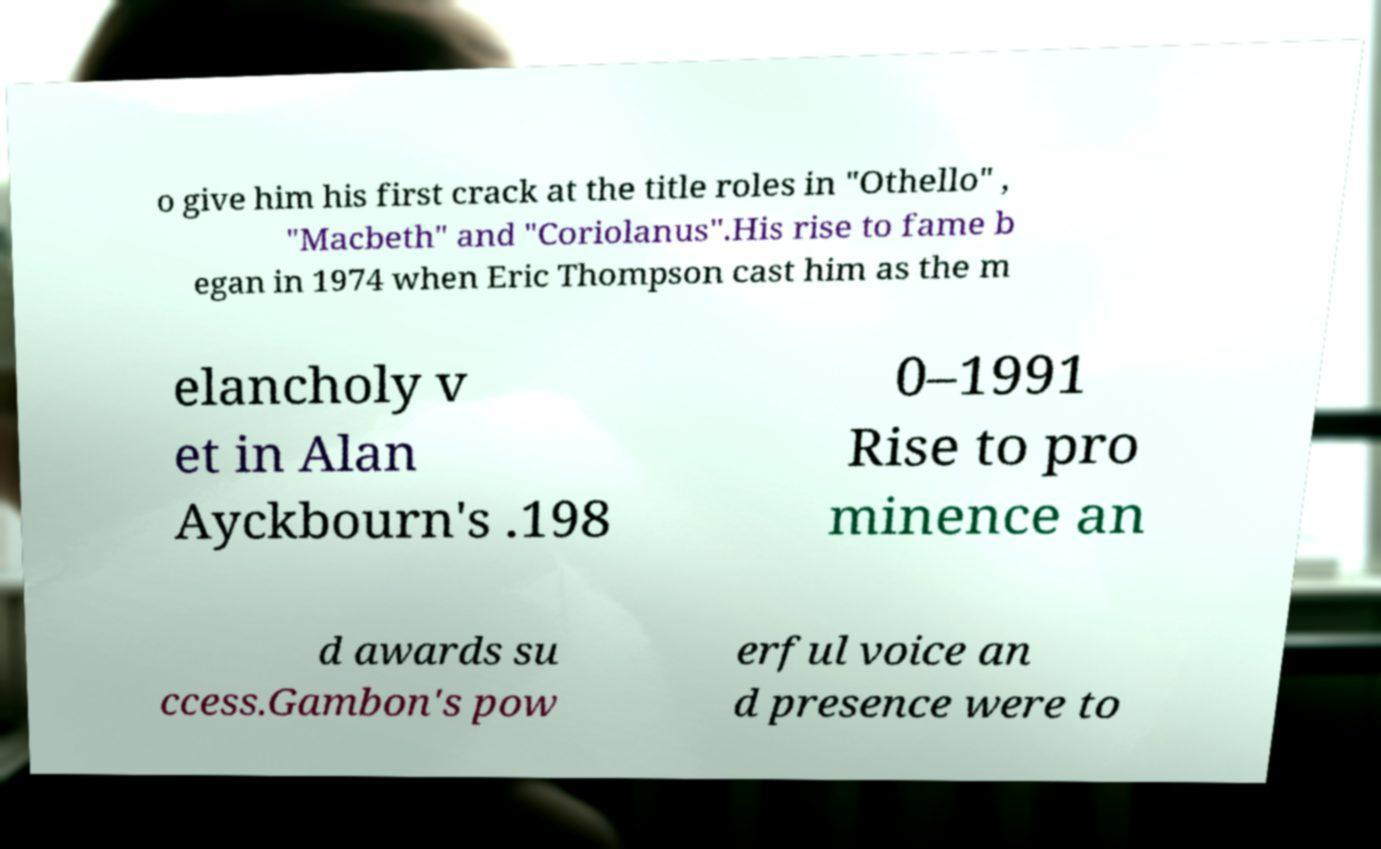Can you accurately transcribe the text from the provided image for me? o give him his first crack at the title roles in "Othello" , "Macbeth" and "Coriolanus".His rise to fame b egan in 1974 when Eric Thompson cast him as the m elancholy v et in Alan Ayckbourn's .198 0–1991 Rise to pro minence an d awards su ccess.Gambon's pow erful voice an d presence were to 